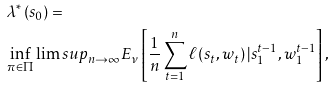<formula> <loc_0><loc_0><loc_500><loc_500>& \lambda ^ { * } \left ( s _ { 0 } \right ) = \\ & \inf _ { \pi \in \Pi } \lim s u p _ { n \rightarrow \infty } E _ { \nu } \left [ \frac { 1 } { n } \sum _ { t = 1 } ^ { n } \ell \left ( s _ { t } , w _ { t } \right ) | s _ { 1 } ^ { t - 1 } , w _ { 1 } ^ { t - 1 } \right ] ,</formula> 